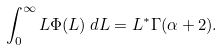Convert formula to latex. <formula><loc_0><loc_0><loc_500><loc_500>\int _ { 0 } ^ { \infty } L \Phi ( L ) \, d L = L ^ { \ast } \Gamma ( \alpha + 2 ) .</formula> 